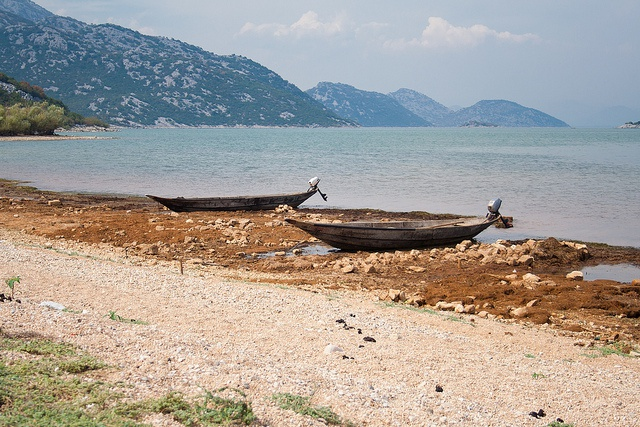Describe the objects in this image and their specific colors. I can see boat in gray, black, and maroon tones and boat in gray, black, and darkgray tones in this image. 